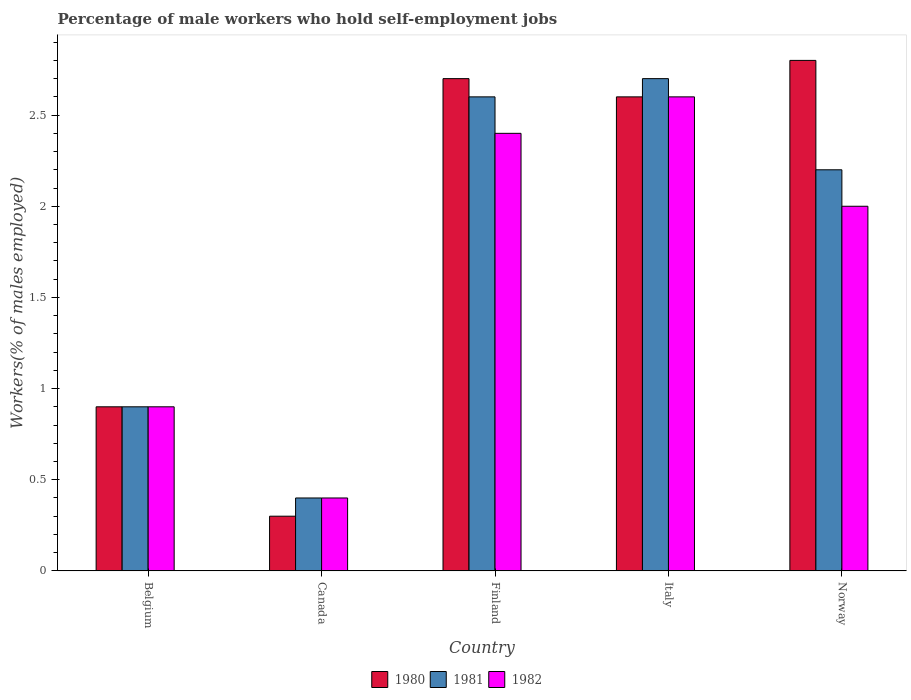How many different coloured bars are there?
Your answer should be compact. 3. Are the number of bars per tick equal to the number of legend labels?
Ensure brevity in your answer.  Yes. Are the number of bars on each tick of the X-axis equal?
Provide a succinct answer. Yes. How many bars are there on the 2nd tick from the right?
Give a very brief answer. 3. What is the percentage of self-employed male workers in 1981 in Norway?
Offer a terse response. 2.2. Across all countries, what is the maximum percentage of self-employed male workers in 1982?
Offer a very short reply. 2.6. Across all countries, what is the minimum percentage of self-employed male workers in 1980?
Give a very brief answer. 0.3. What is the total percentage of self-employed male workers in 1981 in the graph?
Your answer should be very brief. 8.8. What is the difference between the percentage of self-employed male workers in 1981 in Belgium and that in Canada?
Make the answer very short. 0.5. What is the difference between the percentage of self-employed male workers in 1982 in Norway and the percentage of self-employed male workers in 1980 in Belgium?
Provide a succinct answer. 1.1. What is the average percentage of self-employed male workers in 1980 per country?
Ensure brevity in your answer.  1.86. What is the difference between the percentage of self-employed male workers of/in 1982 and percentage of self-employed male workers of/in 1981 in Norway?
Provide a short and direct response. -0.2. In how many countries, is the percentage of self-employed male workers in 1980 greater than 1.7 %?
Provide a short and direct response. 3. What is the ratio of the percentage of self-employed male workers in 1982 in Belgium to that in Italy?
Provide a succinct answer. 0.35. Is the percentage of self-employed male workers in 1980 in Belgium less than that in Italy?
Keep it short and to the point. Yes. What is the difference between the highest and the second highest percentage of self-employed male workers in 1980?
Your answer should be very brief. 0.1. What is the difference between the highest and the lowest percentage of self-employed male workers in 1980?
Keep it short and to the point. 2.5. What does the 1st bar from the left in Belgium represents?
Your answer should be very brief. 1980. What does the 2nd bar from the right in Canada represents?
Your answer should be compact. 1981. How many bars are there?
Provide a short and direct response. 15. Are all the bars in the graph horizontal?
Give a very brief answer. No. Are the values on the major ticks of Y-axis written in scientific E-notation?
Your answer should be very brief. No. Does the graph contain any zero values?
Make the answer very short. No. Where does the legend appear in the graph?
Offer a very short reply. Bottom center. How many legend labels are there?
Make the answer very short. 3. How are the legend labels stacked?
Make the answer very short. Horizontal. What is the title of the graph?
Provide a short and direct response. Percentage of male workers who hold self-employment jobs. Does "1982" appear as one of the legend labels in the graph?
Give a very brief answer. Yes. What is the label or title of the Y-axis?
Your answer should be very brief. Workers(% of males employed). What is the Workers(% of males employed) of 1980 in Belgium?
Provide a short and direct response. 0.9. What is the Workers(% of males employed) of 1981 in Belgium?
Your answer should be compact. 0.9. What is the Workers(% of males employed) of 1982 in Belgium?
Your response must be concise. 0.9. What is the Workers(% of males employed) of 1980 in Canada?
Provide a short and direct response. 0.3. What is the Workers(% of males employed) in 1981 in Canada?
Make the answer very short. 0.4. What is the Workers(% of males employed) in 1982 in Canada?
Give a very brief answer. 0.4. What is the Workers(% of males employed) of 1980 in Finland?
Your response must be concise. 2.7. What is the Workers(% of males employed) in 1981 in Finland?
Provide a short and direct response. 2.6. What is the Workers(% of males employed) of 1982 in Finland?
Give a very brief answer. 2.4. What is the Workers(% of males employed) in 1980 in Italy?
Provide a short and direct response. 2.6. What is the Workers(% of males employed) in 1981 in Italy?
Provide a succinct answer. 2.7. What is the Workers(% of males employed) in 1982 in Italy?
Offer a very short reply. 2.6. What is the Workers(% of males employed) in 1980 in Norway?
Your answer should be compact. 2.8. What is the Workers(% of males employed) of 1981 in Norway?
Your response must be concise. 2.2. What is the Workers(% of males employed) of 1982 in Norway?
Your response must be concise. 2. Across all countries, what is the maximum Workers(% of males employed) of 1980?
Offer a very short reply. 2.8. Across all countries, what is the maximum Workers(% of males employed) of 1981?
Offer a terse response. 2.7. Across all countries, what is the maximum Workers(% of males employed) in 1982?
Make the answer very short. 2.6. Across all countries, what is the minimum Workers(% of males employed) in 1980?
Make the answer very short. 0.3. Across all countries, what is the minimum Workers(% of males employed) of 1981?
Offer a terse response. 0.4. Across all countries, what is the minimum Workers(% of males employed) in 1982?
Provide a short and direct response. 0.4. What is the difference between the Workers(% of males employed) of 1980 in Belgium and that in Canada?
Provide a short and direct response. 0.6. What is the difference between the Workers(% of males employed) of 1981 in Belgium and that in Canada?
Ensure brevity in your answer.  0.5. What is the difference between the Workers(% of males employed) of 1982 in Belgium and that in Canada?
Your answer should be very brief. 0.5. What is the difference between the Workers(% of males employed) of 1982 in Belgium and that in Finland?
Make the answer very short. -1.5. What is the difference between the Workers(% of males employed) of 1981 in Belgium and that in Italy?
Give a very brief answer. -1.8. What is the difference between the Workers(% of males employed) of 1982 in Belgium and that in Italy?
Give a very brief answer. -1.7. What is the difference between the Workers(% of males employed) in 1981 in Belgium and that in Norway?
Make the answer very short. -1.3. What is the difference between the Workers(% of males employed) of 1982 in Belgium and that in Norway?
Keep it short and to the point. -1.1. What is the difference between the Workers(% of males employed) of 1981 in Canada and that in Finland?
Give a very brief answer. -2.2. What is the difference between the Workers(% of males employed) in 1982 in Canada and that in Finland?
Your answer should be compact. -2. What is the difference between the Workers(% of males employed) of 1980 in Canada and that in Norway?
Give a very brief answer. -2.5. What is the difference between the Workers(% of males employed) in 1981 in Canada and that in Norway?
Make the answer very short. -1.8. What is the difference between the Workers(% of males employed) of 1982 in Canada and that in Norway?
Your response must be concise. -1.6. What is the difference between the Workers(% of males employed) of 1980 in Finland and that in Italy?
Your answer should be very brief. 0.1. What is the difference between the Workers(% of males employed) of 1980 in Finland and that in Norway?
Ensure brevity in your answer.  -0.1. What is the difference between the Workers(% of males employed) of 1982 in Finland and that in Norway?
Your answer should be very brief. 0.4. What is the difference between the Workers(% of males employed) of 1981 in Italy and that in Norway?
Give a very brief answer. 0.5. What is the difference between the Workers(% of males employed) in 1982 in Italy and that in Norway?
Offer a terse response. 0.6. What is the difference between the Workers(% of males employed) of 1981 in Belgium and the Workers(% of males employed) of 1982 in Canada?
Your answer should be compact. 0.5. What is the difference between the Workers(% of males employed) of 1980 in Belgium and the Workers(% of males employed) of 1982 in Finland?
Offer a very short reply. -1.5. What is the difference between the Workers(% of males employed) of 1980 in Belgium and the Workers(% of males employed) of 1982 in Italy?
Provide a succinct answer. -1.7. What is the difference between the Workers(% of males employed) of 1980 in Belgium and the Workers(% of males employed) of 1981 in Norway?
Offer a terse response. -1.3. What is the difference between the Workers(% of males employed) of 1980 in Canada and the Workers(% of males employed) of 1982 in Italy?
Provide a short and direct response. -2.3. What is the difference between the Workers(% of males employed) in 1980 in Canada and the Workers(% of males employed) in 1981 in Norway?
Your answer should be compact. -1.9. What is the difference between the Workers(% of males employed) of 1980 in Canada and the Workers(% of males employed) of 1982 in Norway?
Ensure brevity in your answer.  -1.7. What is the difference between the Workers(% of males employed) of 1981 in Finland and the Workers(% of males employed) of 1982 in Italy?
Give a very brief answer. 0. What is the difference between the Workers(% of males employed) in 1980 in Finland and the Workers(% of males employed) in 1982 in Norway?
Offer a very short reply. 0.7. What is the difference between the Workers(% of males employed) of 1981 in Finland and the Workers(% of males employed) of 1982 in Norway?
Keep it short and to the point. 0.6. What is the difference between the Workers(% of males employed) of 1980 in Italy and the Workers(% of males employed) of 1981 in Norway?
Keep it short and to the point. 0.4. What is the difference between the Workers(% of males employed) in 1980 in Italy and the Workers(% of males employed) in 1982 in Norway?
Your answer should be very brief. 0.6. What is the average Workers(% of males employed) in 1980 per country?
Offer a terse response. 1.86. What is the average Workers(% of males employed) in 1981 per country?
Keep it short and to the point. 1.76. What is the average Workers(% of males employed) in 1982 per country?
Ensure brevity in your answer.  1.66. What is the difference between the Workers(% of males employed) in 1980 and Workers(% of males employed) in 1981 in Belgium?
Your answer should be compact. 0. What is the difference between the Workers(% of males employed) in 1980 and Workers(% of males employed) in 1982 in Belgium?
Provide a succinct answer. 0. What is the difference between the Workers(% of males employed) of 1980 and Workers(% of males employed) of 1981 in Canada?
Keep it short and to the point. -0.1. What is the difference between the Workers(% of males employed) of 1980 and Workers(% of males employed) of 1982 in Canada?
Your response must be concise. -0.1. What is the difference between the Workers(% of males employed) of 1981 and Workers(% of males employed) of 1982 in Canada?
Your answer should be very brief. 0. What is the difference between the Workers(% of males employed) of 1980 and Workers(% of males employed) of 1982 in Finland?
Your answer should be compact. 0.3. What is the difference between the Workers(% of males employed) of 1980 and Workers(% of males employed) of 1981 in Italy?
Make the answer very short. -0.1. What is the difference between the Workers(% of males employed) of 1980 and Workers(% of males employed) of 1982 in Italy?
Give a very brief answer. 0. What is the difference between the Workers(% of males employed) of 1981 and Workers(% of males employed) of 1982 in Italy?
Offer a terse response. 0.1. What is the difference between the Workers(% of males employed) in 1980 and Workers(% of males employed) in 1981 in Norway?
Offer a very short reply. 0.6. What is the difference between the Workers(% of males employed) in 1980 and Workers(% of males employed) in 1982 in Norway?
Keep it short and to the point. 0.8. What is the ratio of the Workers(% of males employed) of 1981 in Belgium to that in Canada?
Your answer should be very brief. 2.25. What is the ratio of the Workers(% of males employed) in 1982 in Belgium to that in Canada?
Make the answer very short. 2.25. What is the ratio of the Workers(% of males employed) of 1980 in Belgium to that in Finland?
Keep it short and to the point. 0.33. What is the ratio of the Workers(% of males employed) in 1981 in Belgium to that in Finland?
Offer a terse response. 0.35. What is the ratio of the Workers(% of males employed) in 1982 in Belgium to that in Finland?
Provide a succinct answer. 0.38. What is the ratio of the Workers(% of males employed) of 1980 in Belgium to that in Italy?
Offer a terse response. 0.35. What is the ratio of the Workers(% of males employed) in 1982 in Belgium to that in Italy?
Offer a terse response. 0.35. What is the ratio of the Workers(% of males employed) in 1980 in Belgium to that in Norway?
Provide a short and direct response. 0.32. What is the ratio of the Workers(% of males employed) in 1981 in Belgium to that in Norway?
Your answer should be very brief. 0.41. What is the ratio of the Workers(% of males employed) in 1982 in Belgium to that in Norway?
Give a very brief answer. 0.45. What is the ratio of the Workers(% of males employed) in 1980 in Canada to that in Finland?
Provide a short and direct response. 0.11. What is the ratio of the Workers(% of males employed) of 1981 in Canada to that in Finland?
Your answer should be very brief. 0.15. What is the ratio of the Workers(% of males employed) in 1980 in Canada to that in Italy?
Your answer should be compact. 0.12. What is the ratio of the Workers(% of males employed) in 1981 in Canada to that in Italy?
Ensure brevity in your answer.  0.15. What is the ratio of the Workers(% of males employed) of 1982 in Canada to that in Italy?
Offer a very short reply. 0.15. What is the ratio of the Workers(% of males employed) of 1980 in Canada to that in Norway?
Keep it short and to the point. 0.11. What is the ratio of the Workers(% of males employed) in 1981 in Canada to that in Norway?
Your answer should be very brief. 0.18. What is the ratio of the Workers(% of males employed) of 1982 in Canada to that in Norway?
Give a very brief answer. 0.2. What is the ratio of the Workers(% of males employed) in 1980 in Finland to that in Italy?
Give a very brief answer. 1.04. What is the ratio of the Workers(% of males employed) of 1981 in Finland to that in Norway?
Give a very brief answer. 1.18. What is the ratio of the Workers(% of males employed) of 1981 in Italy to that in Norway?
Provide a short and direct response. 1.23. What is the ratio of the Workers(% of males employed) in 1982 in Italy to that in Norway?
Ensure brevity in your answer.  1.3. What is the difference between the highest and the second highest Workers(% of males employed) of 1981?
Give a very brief answer. 0.1. What is the difference between the highest and the lowest Workers(% of males employed) of 1980?
Ensure brevity in your answer.  2.5. What is the difference between the highest and the lowest Workers(% of males employed) in 1981?
Your response must be concise. 2.3. 